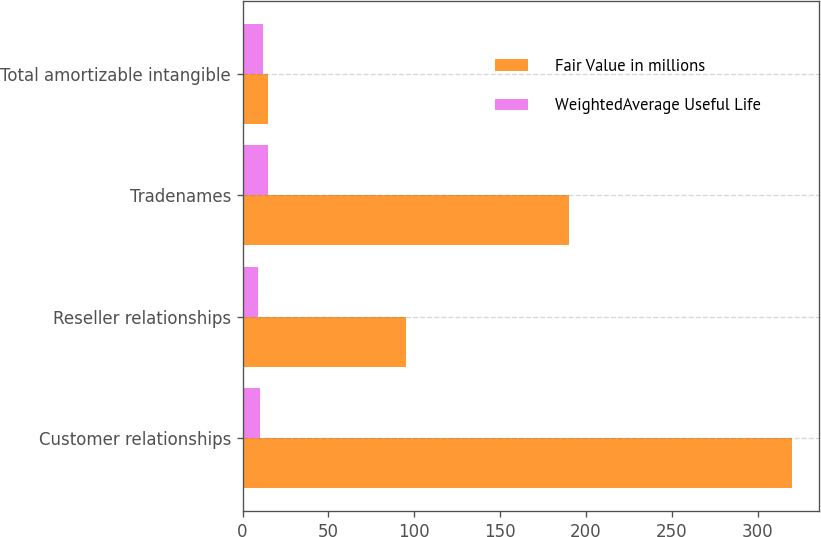Convert chart. <chart><loc_0><loc_0><loc_500><loc_500><stacked_bar_chart><ecel><fcel>Customer relationships<fcel>Reseller relationships<fcel>Tradenames<fcel>Total amortizable intangible<nl><fcel>Fair Value in millions<fcel>320<fcel>95<fcel>190<fcel>15<nl><fcel>WeightedAverage Useful Life<fcel>10<fcel>9<fcel>15<fcel>12<nl></chart> 